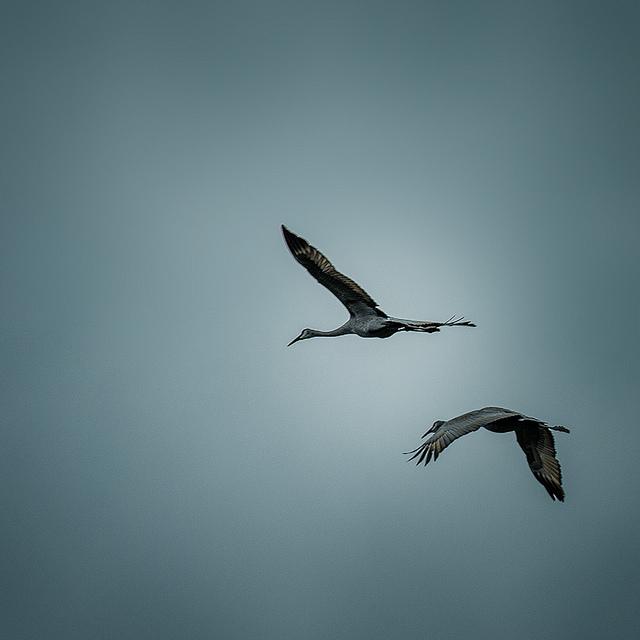Is it blue skies?
Short answer required. Yes. How many birds are in the air?
Give a very brief answer. 2. Is this a bird or duck?
Write a very short answer. Bird. Where is the smaller bird?
Be succinct. Bottom. Is the bird flying?
Concise answer only. Yes. Is this bird all alone?
Give a very brief answer. No. What kind of birds are these?
Concise answer only. Stork. Are these scavengers?
Write a very short answer. No. Is the second bird following the first one?
Concise answer only. No. Which bird flies at a higher altitude?
Give a very brief answer. Top one. Are the birds on top of a lake?
Answer briefly. No. How many birds?
Short answer required. 2. What is the bird doing?
Be succinct. Flying. Are these birds eagles?
Be succinct. No. Are they the same color?
Write a very short answer. Yes. What type of birds are they?
Be succinct. Stork. Why aren't there any feathers on its neck?
Short answer required. There are. What type of birds are in the picture?
Be succinct. Stork. Are both birds the same?
Write a very short answer. Yes. Hazy or sunny?
Write a very short answer. Hazy. How many birds are flying?
Keep it brief. 2. 